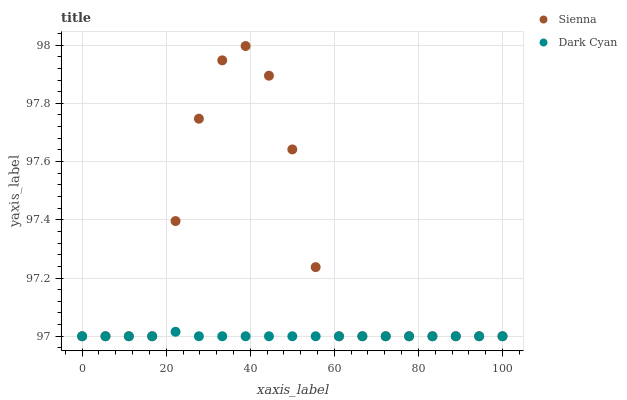Does Dark Cyan have the minimum area under the curve?
Answer yes or no. Yes. Does Sienna have the maximum area under the curve?
Answer yes or no. Yes. Does Dark Cyan have the maximum area under the curve?
Answer yes or no. No. Is Dark Cyan the smoothest?
Answer yes or no. Yes. Is Sienna the roughest?
Answer yes or no. Yes. Is Dark Cyan the roughest?
Answer yes or no. No. Does Sienna have the lowest value?
Answer yes or no. Yes. Does Sienna have the highest value?
Answer yes or no. Yes. Does Dark Cyan have the highest value?
Answer yes or no. No. Does Sienna intersect Dark Cyan?
Answer yes or no. Yes. Is Sienna less than Dark Cyan?
Answer yes or no. No. Is Sienna greater than Dark Cyan?
Answer yes or no. No. 